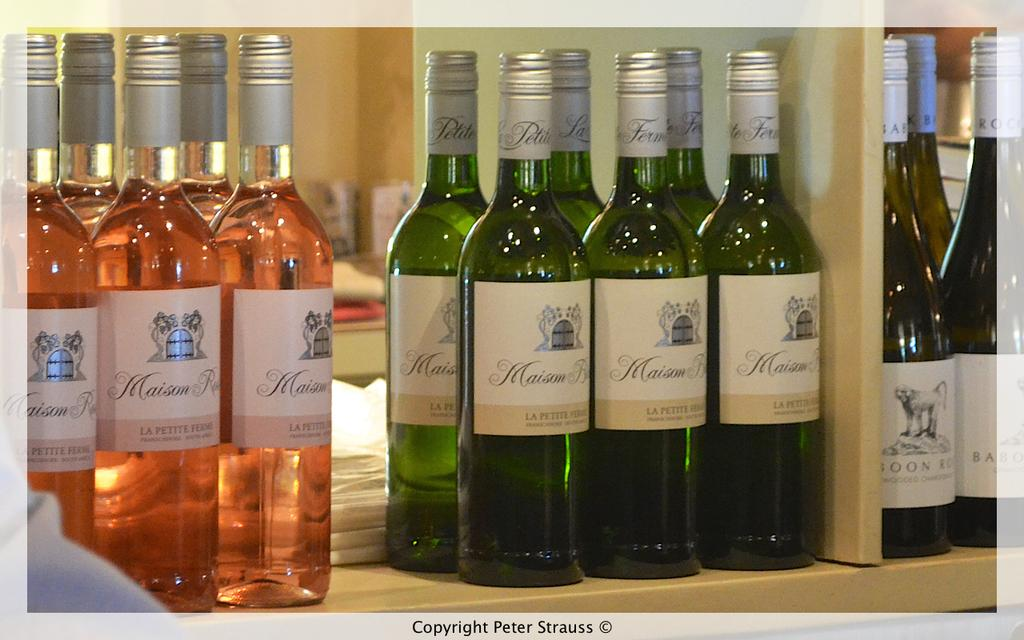<image>
Summarize the visual content of the image. Many bottles of Maison Le Petite liquor in green and pink bottles. 